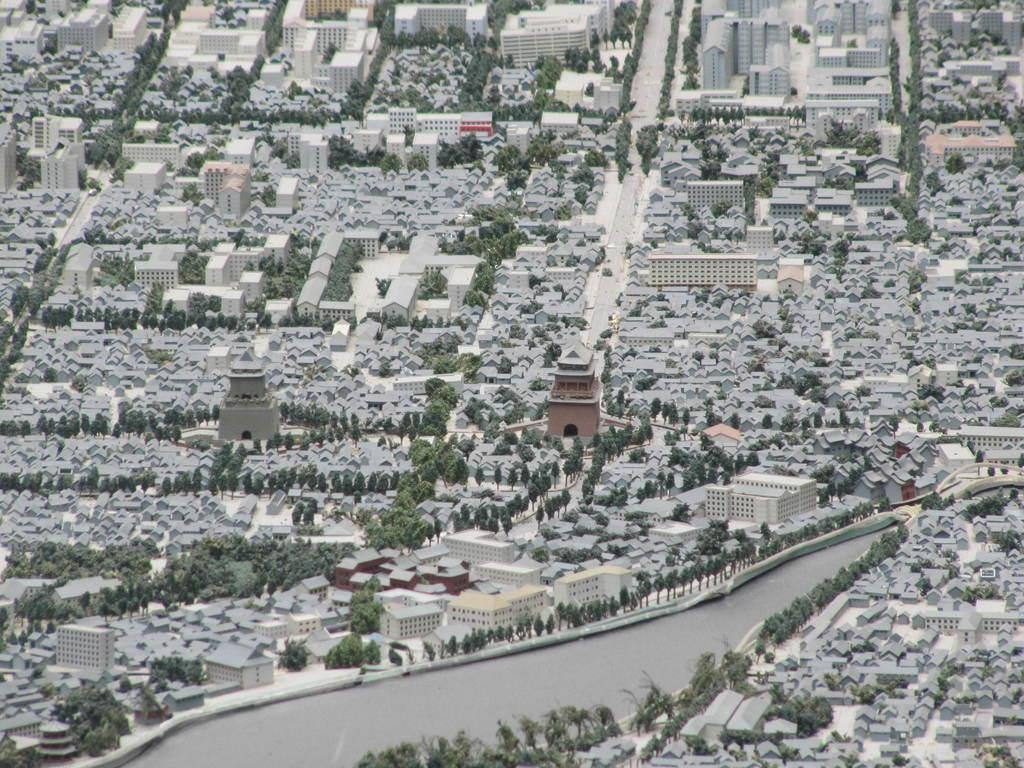What can be seen in the image that is liquid? There is water visible in the image. What type of vegetation is present in the image? There are green trees in the image. What type of structures can be seen in the image? There are grey roofs of buildings in the image. What type of pathway is visible in the image? There is a road visible in the image. Where is the chessboard located in the image? There is no chessboard present in the image. What type of mine is visible in the image? There is no mine present in the image. 